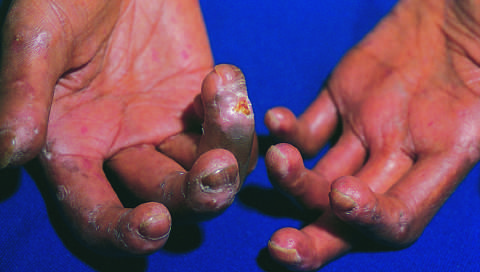does the extensive subcutaneous fibrosis create a clawlike flexion deformity?
Answer the question using a single word or phrase. Yes 